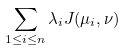Convert formula to latex. <formula><loc_0><loc_0><loc_500><loc_500>\sum _ { 1 \leq i \leq n } \lambda _ { i } J ( \mu _ { i } , \nu )</formula> 